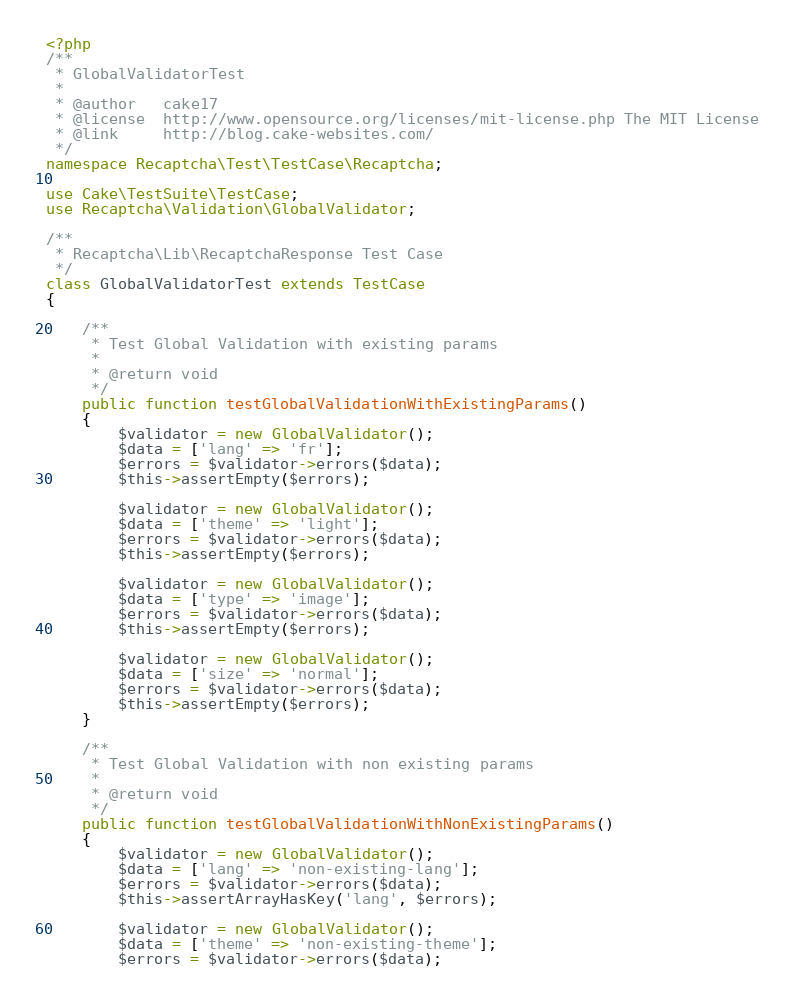Convert code to text. <code><loc_0><loc_0><loc_500><loc_500><_PHP_><?php
/**
 * GlobalValidatorTest
 *
 * @author   cake17
 * @license  http://www.opensource.org/licenses/mit-license.php The MIT License
 * @link     http://blog.cake-websites.com/
 */
namespace Recaptcha\Test\TestCase\Recaptcha;

use Cake\TestSuite\TestCase;
use Recaptcha\Validation\GlobalValidator;

/**
 * Recaptcha\Lib\RecaptchaResponse Test Case
 */
class GlobalValidatorTest extends TestCase
{

    /**
     * Test Global Validation with existing params
     *
     * @return void
     */
    public function testGlobalValidationWithExistingParams()
    {
        $validator = new GlobalValidator();
        $data = ['lang' => 'fr'];
        $errors = $validator->errors($data);
        $this->assertEmpty($errors);

        $validator = new GlobalValidator();
        $data = ['theme' => 'light'];
        $errors = $validator->errors($data);
        $this->assertEmpty($errors);

        $validator = new GlobalValidator();
        $data = ['type' => 'image'];
        $errors = $validator->errors($data);
        $this->assertEmpty($errors);

        $validator = new GlobalValidator();
        $data = ['size' => 'normal'];
        $errors = $validator->errors($data);
        $this->assertEmpty($errors);
    }

    /**
     * Test Global Validation with non existing params
     *
     * @return void
     */
    public function testGlobalValidationWithNonExistingParams()
    {
        $validator = new GlobalValidator();
        $data = ['lang' => 'non-existing-lang'];
        $errors = $validator->errors($data);
        $this->assertArrayHasKey('lang', $errors);

        $validator = new GlobalValidator();
        $data = ['theme' => 'non-existing-theme'];
        $errors = $validator->errors($data);</code> 